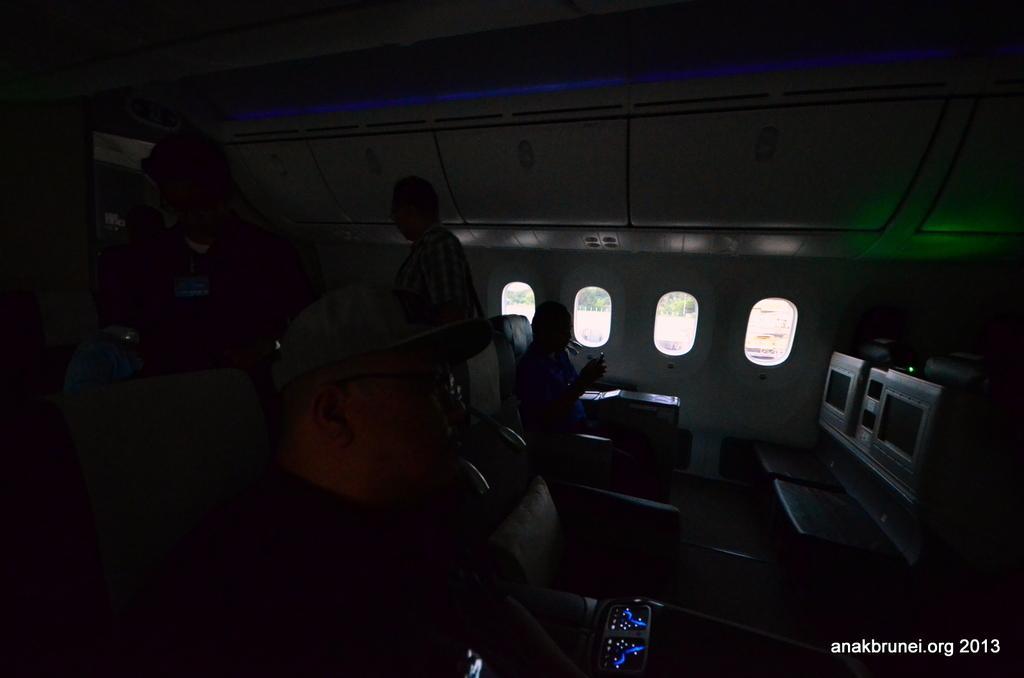Could you give a brief overview of what you see in this image? In this image, there is an inside view of an airplane. There is a person in the middle of the image sitting on the chair beside the window. There are two person in this image, standing and wearing clothes. There is a person at the bottom of the image wearing a cap. 